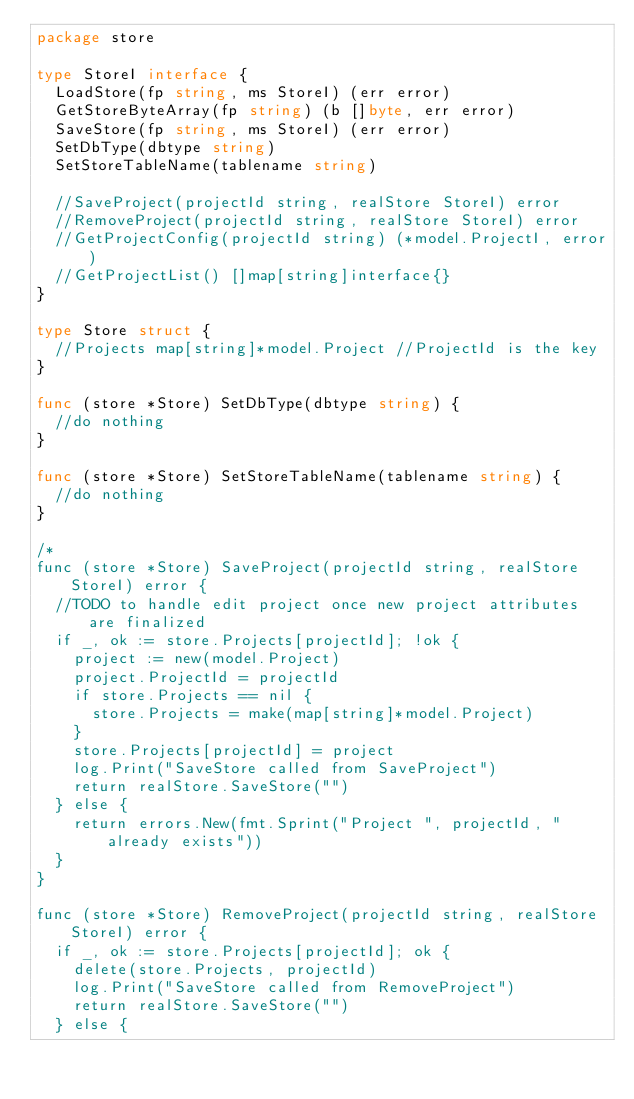<code> <loc_0><loc_0><loc_500><loc_500><_Go_>package store

type StoreI interface {
	LoadStore(fp string, ms StoreI) (err error)
	GetStoreByteArray(fp string) (b []byte, err error)
	SaveStore(fp string, ms StoreI) (err error)
	SetDbType(dbtype string)
	SetStoreTableName(tablename string)

	//SaveProject(projectId string, realStore StoreI) error
	//RemoveProject(projectId string, realStore StoreI) error
	//GetProjectConfig(projectId string) (*model.ProjectI, error)
	//GetProjectList() []map[string]interface{}
}

type Store struct {
	//Projects map[string]*model.Project //ProjectId is the key
}

func (store *Store) SetDbType(dbtype string) {
	//do nothing
}

func (store *Store) SetStoreTableName(tablename string) {
	//do nothing
}

/*
func (store *Store) SaveProject(projectId string, realStore StoreI) error {
	//TODO to handle edit project once new project attributes are finalized
	if _, ok := store.Projects[projectId]; !ok {
		project := new(model.Project)
		project.ProjectId = projectId
		if store.Projects == nil {
			store.Projects = make(map[string]*model.Project)
		}
		store.Projects[projectId] = project
		log.Print("SaveStore called from SaveProject")
		return realStore.SaveStore("")
	} else {
		return errors.New(fmt.Sprint("Project ", projectId, " already exists"))
	}
}

func (store *Store) RemoveProject(projectId string, realStore StoreI) error {
	if _, ok := store.Projects[projectId]; ok {
		delete(store.Projects, projectId)
		log.Print("SaveStore called from RemoveProject")
		return realStore.SaveStore("")
	} else {</code> 